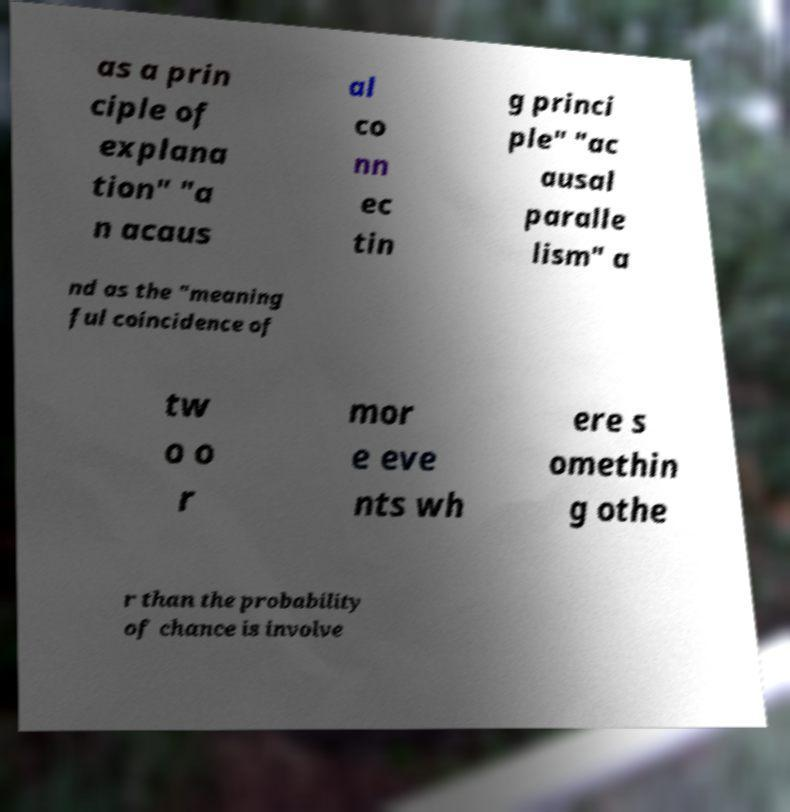For documentation purposes, I need the text within this image transcribed. Could you provide that? as a prin ciple of explana tion" "a n acaus al co nn ec tin g princi ple" "ac ausal paralle lism" a nd as the "meaning ful coincidence of tw o o r mor e eve nts wh ere s omethin g othe r than the probability of chance is involve 